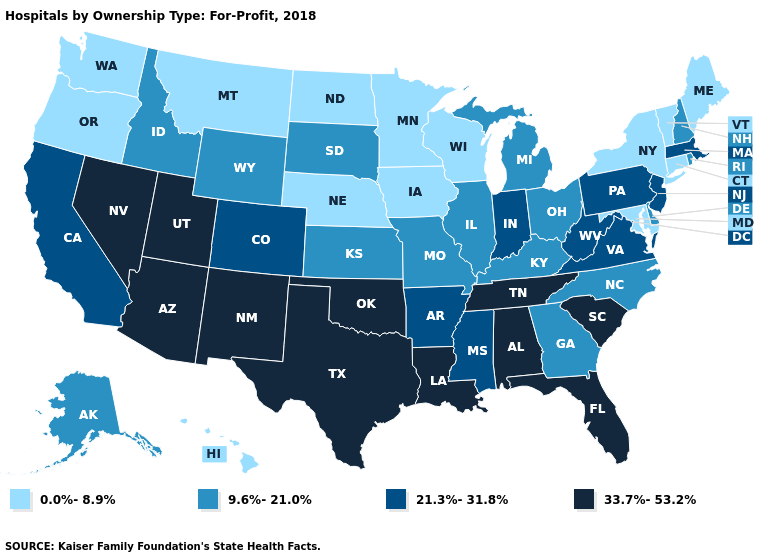Among the states that border Massachusetts , does Connecticut have the highest value?
Short answer required. No. What is the highest value in states that border California?
Answer briefly. 33.7%-53.2%. Does Pennsylvania have the highest value in the Northeast?
Write a very short answer. Yes. Name the states that have a value in the range 21.3%-31.8%?
Answer briefly. Arkansas, California, Colorado, Indiana, Massachusetts, Mississippi, New Jersey, Pennsylvania, Virginia, West Virginia. Name the states that have a value in the range 21.3%-31.8%?
Keep it brief. Arkansas, California, Colorado, Indiana, Massachusetts, Mississippi, New Jersey, Pennsylvania, Virginia, West Virginia. What is the lowest value in the South?
Concise answer only. 0.0%-8.9%. What is the highest value in the South ?
Be succinct. 33.7%-53.2%. Among the states that border Illinois , which have the highest value?
Concise answer only. Indiana. Does Oklahoma have the highest value in the USA?
Give a very brief answer. Yes. Among the states that border Delaware , does Maryland have the lowest value?
Write a very short answer. Yes. Does Illinois have a higher value than New Jersey?
Concise answer only. No. Does Michigan have the same value as Hawaii?
Answer briefly. No. What is the highest value in the West ?
Keep it brief. 33.7%-53.2%. Does Colorado have a higher value than Wisconsin?
Concise answer only. Yes. What is the value of Wyoming?
Answer briefly. 9.6%-21.0%. 